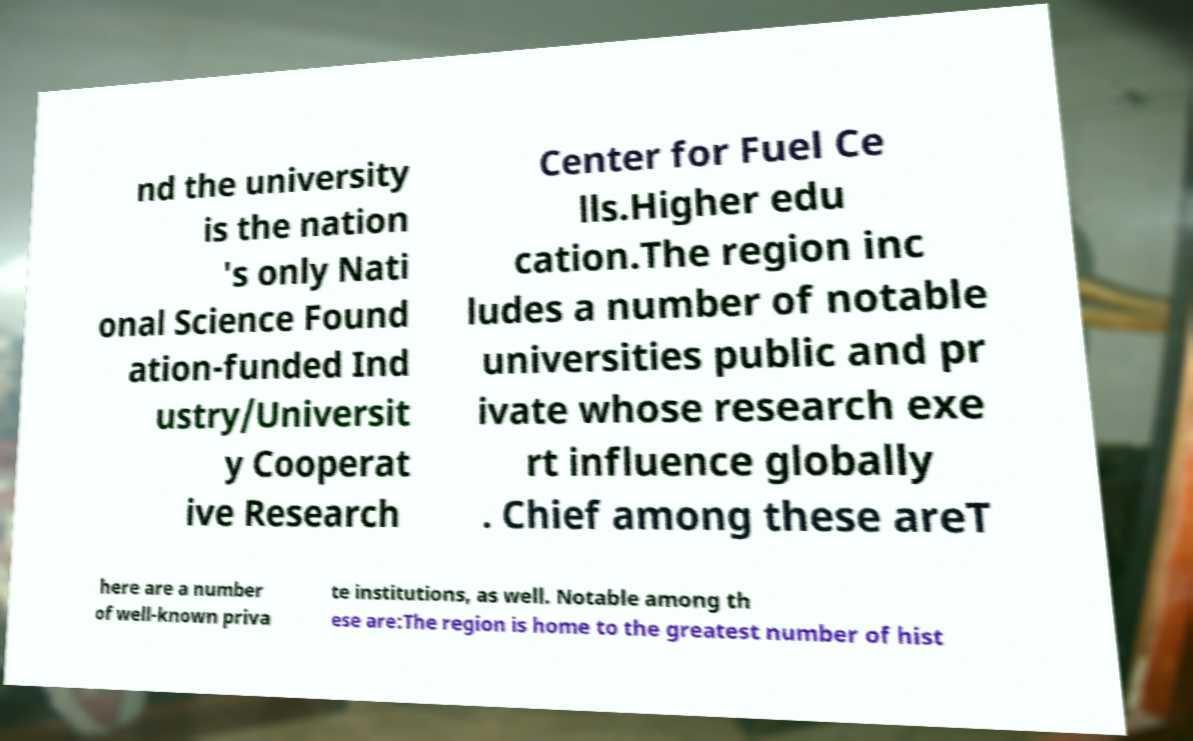For documentation purposes, I need the text within this image transcribed. Could you provide that? nd the university is the nation 's only Nati onal Science Found ation-funded Ind ustry/Universit y Cooperat ive Research Center for Fuel Ce lls.Higher edu cation.The region inc ludes a number of notable universities public and pr ivate whose research exe rt influence globally . Chief among these areT here are a number of well-known priva te institutions, as well. Notable among th ese are:The region is home to the greatest number of hist 